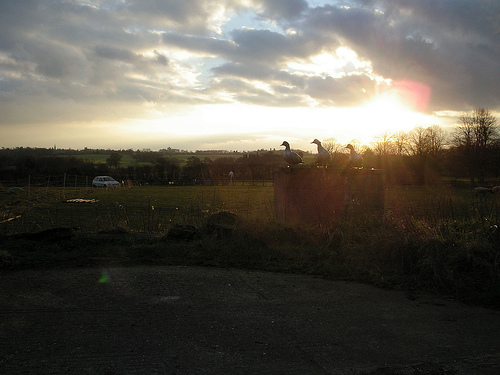<image>
Can you confirm if the bird is in the sky? No. The bird is not contained within the sky. These objects have a different spatial relationship. 